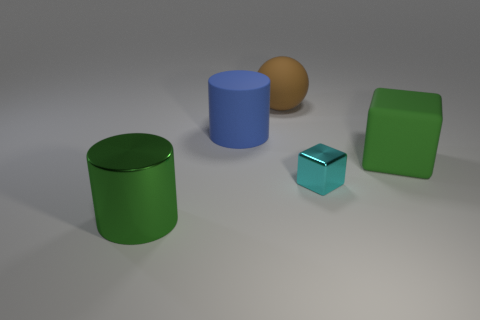What is the color of the big rubber thing that is the same shape as the large shiny object?
Keep it short and to the point. Blue. What is the color of the cylinder that is the same material as the cyan thing?
Your answer should be very brief. Green. Are there the same number of cyan objects on the left side of the cyan cube and big matte objects?
Provide a short and direct response. No. Do the cube left of the green rubber block and the blue rubber cylinder have the same size?
Offer a very short reply. No. What is the color of the metallic object that is the same size as the green block?
Provide a succinct answer. Green. Is there a green object left of the big cylinder that is behind the green object behind the green shiny cylinder?
Provide a succinct answer. Yes. There is a large cylinder in front of the small cyan object; what material is it?
Offer a terse response. Metal. Do the big green matte object and the big thing behind the large blue cylinder have the same shape?
Offer a very short reply. No. Are there an equal number of matte objects on the left side of the big green cylinder and big balls in front of the blue rubber cylinder?
Provide a succinct answer. Yes. How many other things are the same material as the big brown thing?
Make the answer very short. 2. 